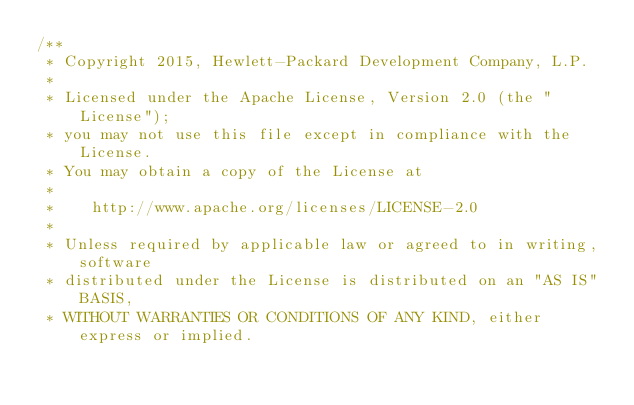Convert code to text. <code><loc_0><loc_0><loc_500><loc_500><_JavaScript_>/**
 * Copyright 2015, Hewlett-Packard Development Company, L.P.
 *
 * Licensed under the Apache License, Version 2.0 (the "License");
 * you may not use this file except in compliance with the License.
 * You may obtain a copy of the License at
 *
 *    http://www.apache.org/licenses/LICENSE-2.0
 *
 * Unless required by applicable law or agreed to in writing, software
 * distributed under the License is distributed on an "AS IS" BASIS,
 * WITHOUT WARRANTIES OR CONDITIONS OF ANY KIND, either express or implied.</code> 